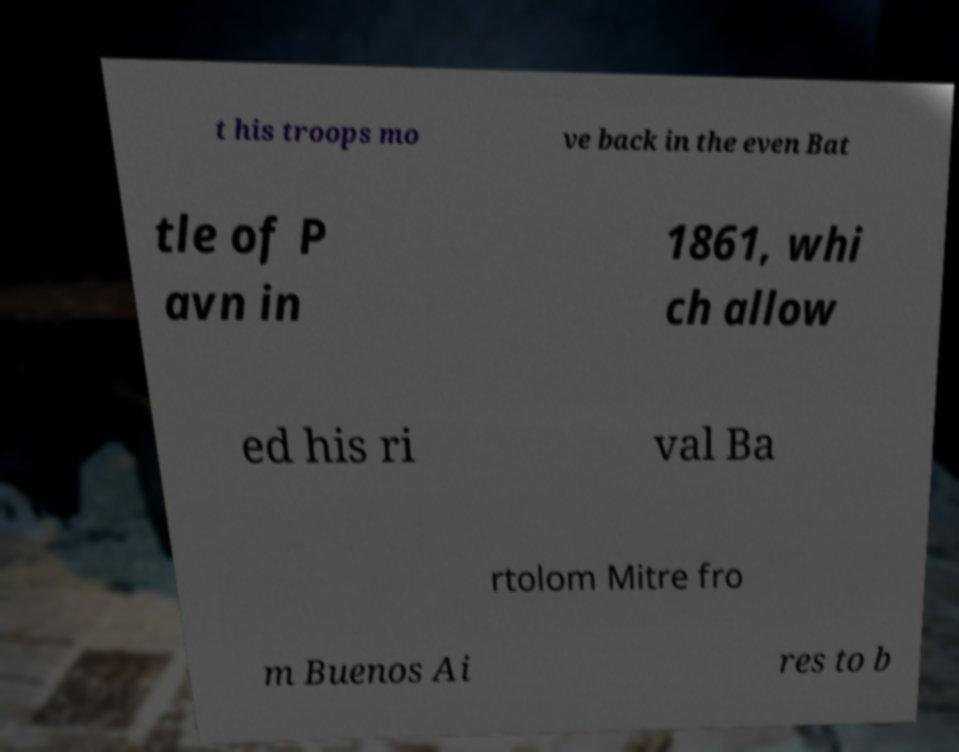Could you extract and type out the text from this image? t his troops mo ve back in the even Bat tle of P avn in 1861, whi ch allow ed his ri val Ba rtolom Mitre fro m Buenos Ai res to b 